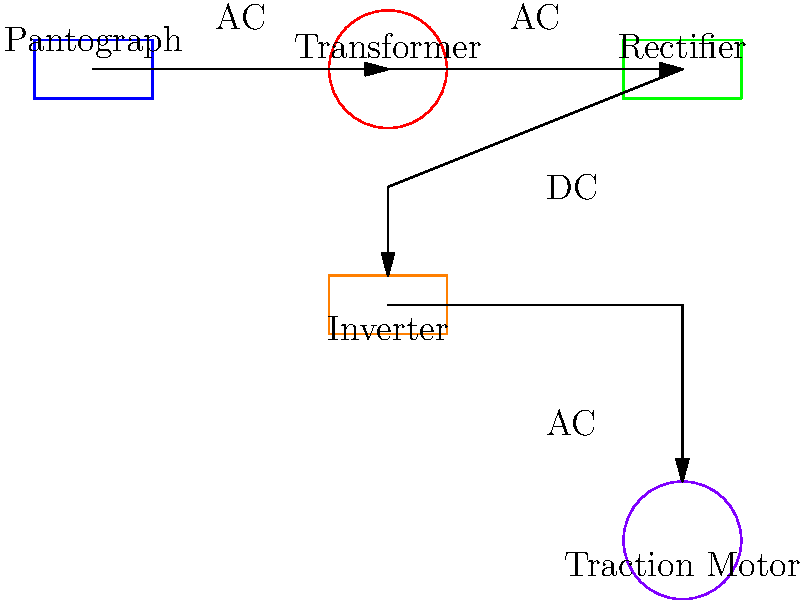In the block diagram of a train's power distribution system shown above, what is the purpose of the component labeled "Rectifier"? To understand the purpose of the rectifier in a train's power distribution system, let's follow the power flow:

1. The pantograph collects alternating current (AC) from the overhead lines.
2. This AC power is then passed through a transformer, which adjusts the voltage to a suitable level for the train's systems.
3. The AC power then reaches the rectifier. The rectifier's primary function is to convert the alternating current (AC) into direct current (DC).
4. This DC power is then fed to the inverter, which converts it back to AC but at a variable frequency.
5. Finally, this variable frequency AC power is used to control the traction motors, allowing for speed control of the train.

The rectifier is crucial because many of the train's systems, including the inverter, require DC power to operate efficiently. By converting the high-voltage AC from the overhead lines to DC, the rectifier enables better control and distribution of power throughout the train's electrical systems.
Answer: To convert AC to DC 